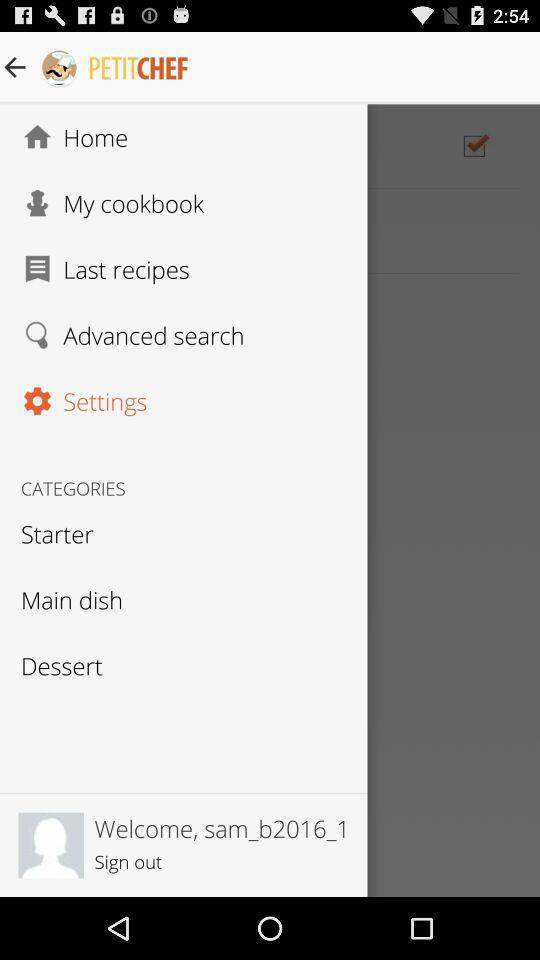How many recipes are there in "My cookbook"?
When the provided information is insufficient, respond with <no answer>. <no answer> 